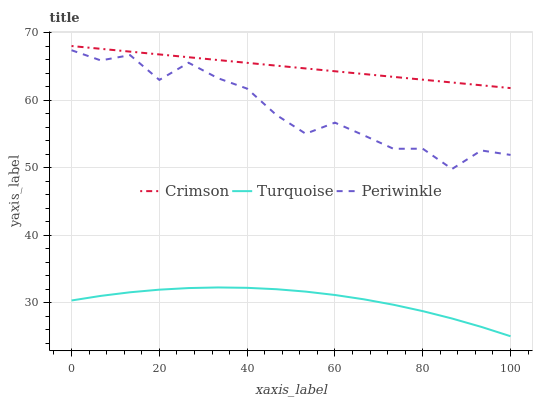Does Turquoise have the minimum area under the curve?
Answer yes or no. Yes. Does Crimson have the maximum area under the curve?
Answer yes or no. Yes. Does Periwinkle have the minimum area under the curve?
Answer yes or no. No. Does Periwinkle have the maximum area under the curve?
Answer yes or no. No. Is Crimson the smoothest?
Answer yes or no. Yes. Is Periwinkle the roughest?
Answer yes or no. Yes. Is Turquoise the smoothest?
Answer yes or no. No. Is Turquoise the roughest?
Answer yes or no. No. Does Turquoise have the lowest value?
Answer yes or no. Yes. Does Periwinkle have the lowest value?
Answer yes or no. No. Does Crimson have the highest value?
Answer yes or no. Yes. Does Periwinkle have the highest value?
Answer yes or no. No. Is Turquoise less than Periwinkle?
Answer yes or no. Yes. Is Crimson greater than Turquoise?
Answer yes or no. Yes. Does Turquoise intersect Periwinkle?
Answer yes or no. No. 